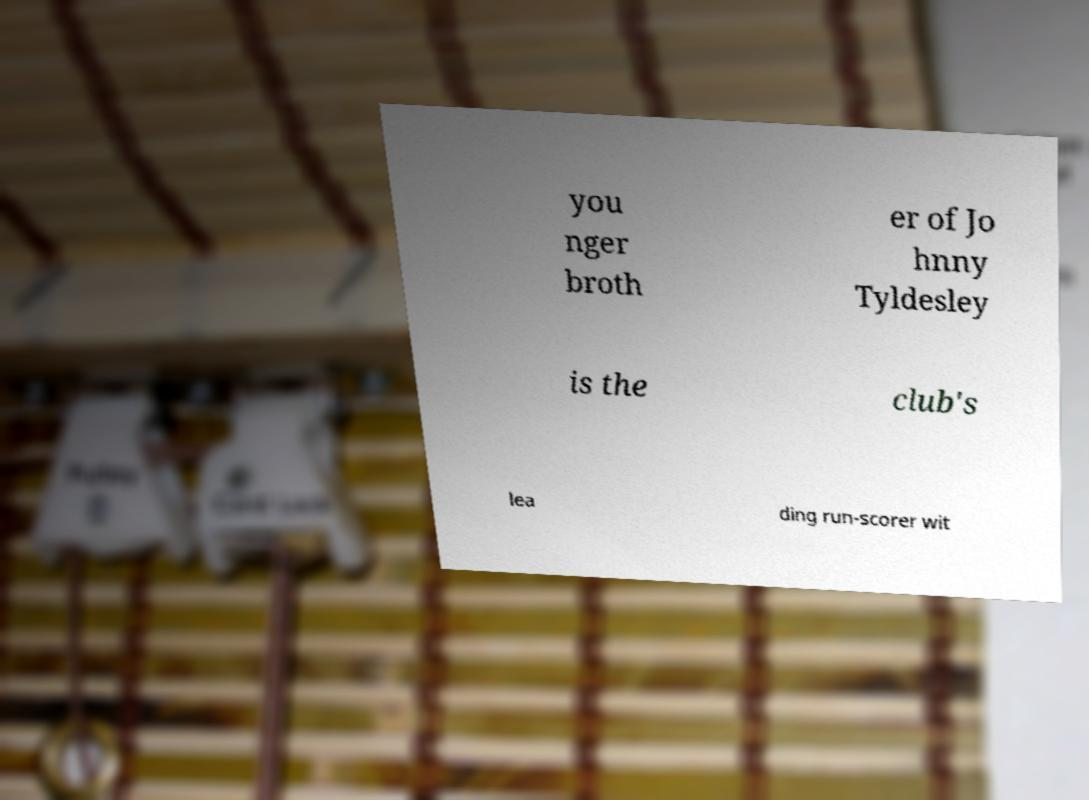Could you extract and type out the text from this image? you nger broth er of Jo hnny Tyldesley is the club's lea ding run-scorer wit 